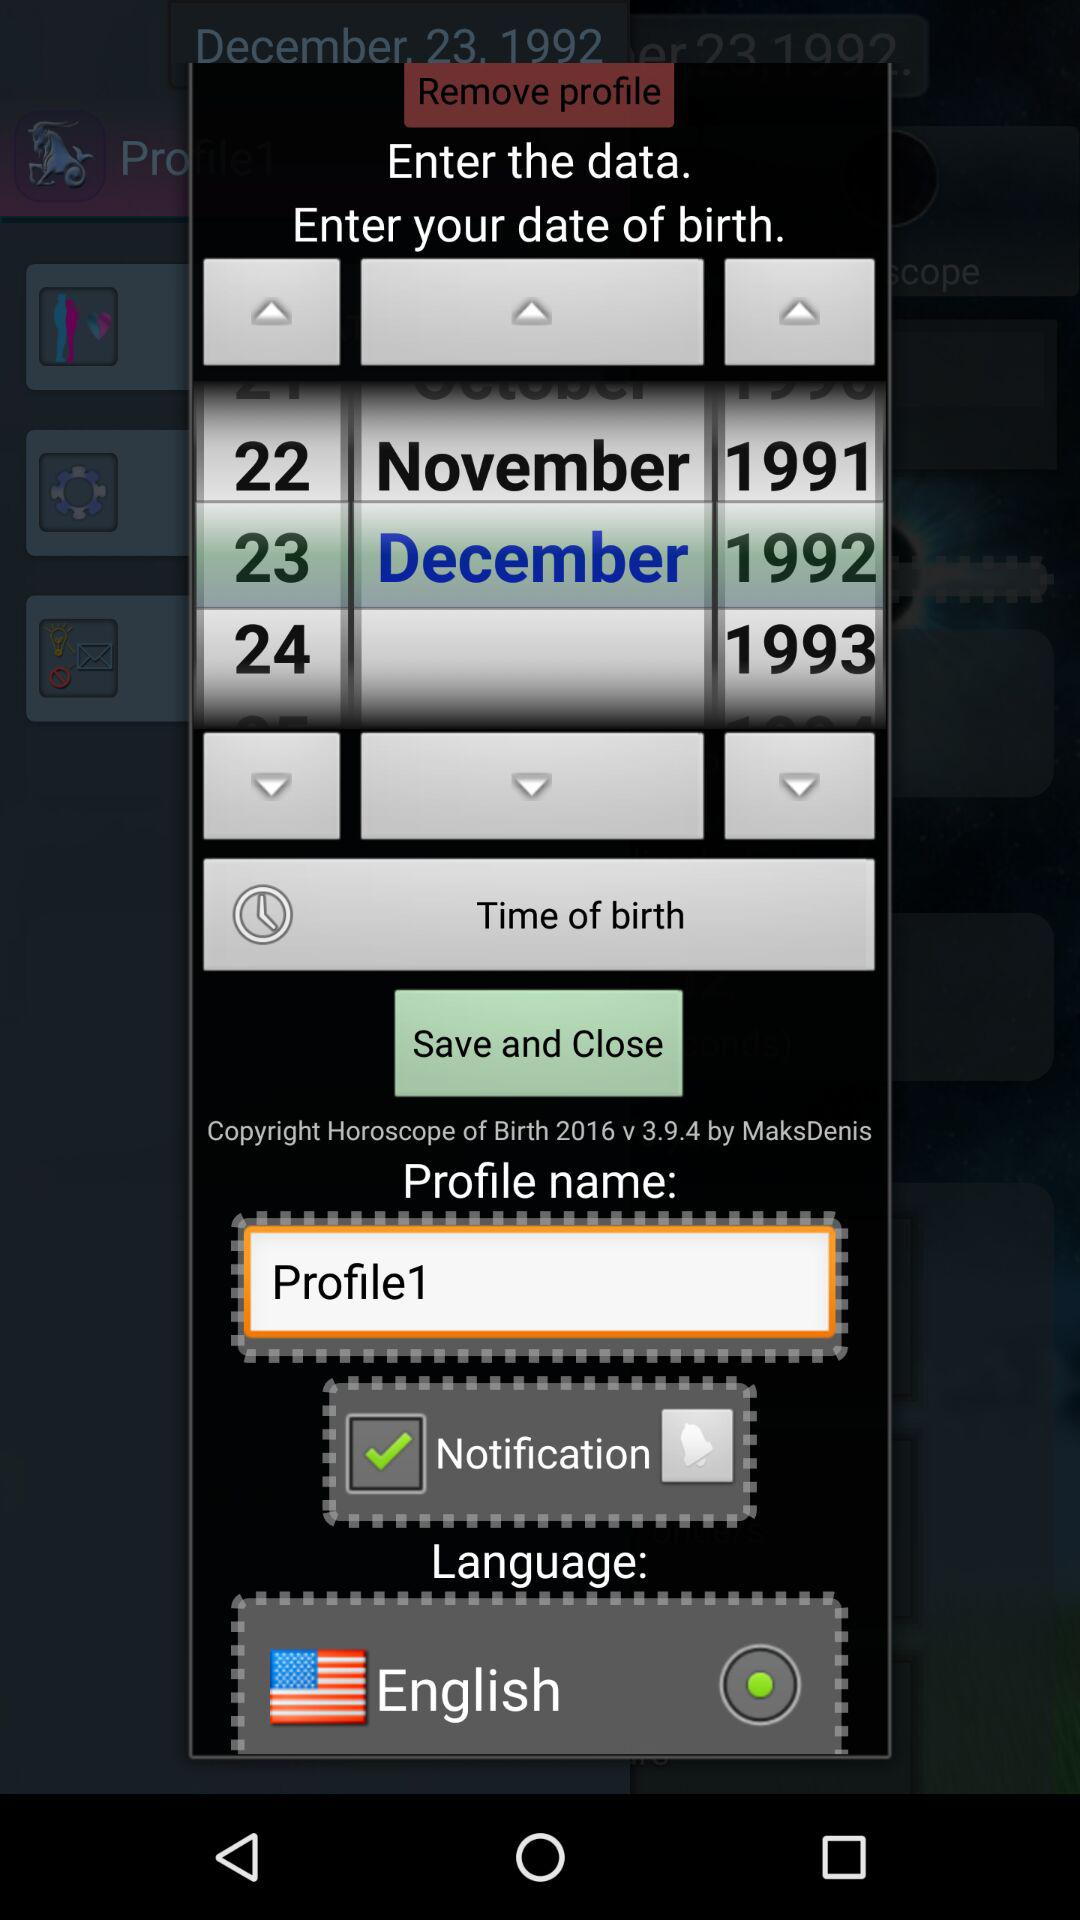What is the status of "Notification"? The status is "on". 